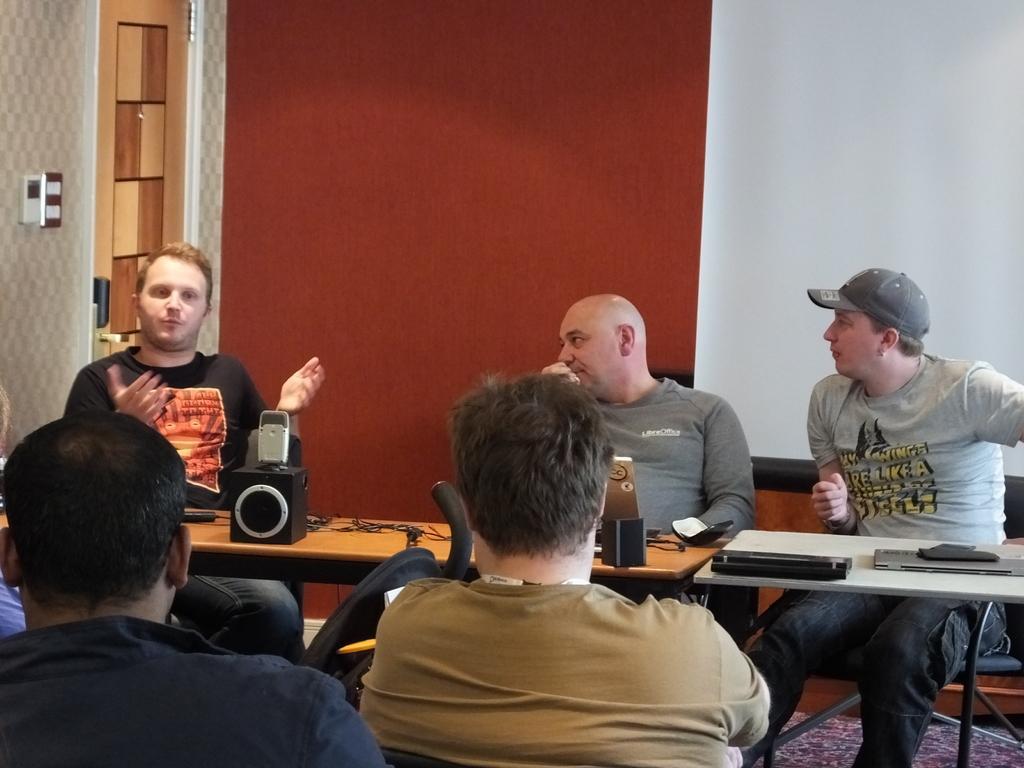Could you give a brief overview of what you see in this image? people are seated around the table. on the table there is a speaker, wires, laptop. the person a the left is wearing a black and a orange t shirt and speaking. everyone else is listening to him. behind them there is a red and white wall. at the left there is a door. the person at the right is wearing a grey cap. 